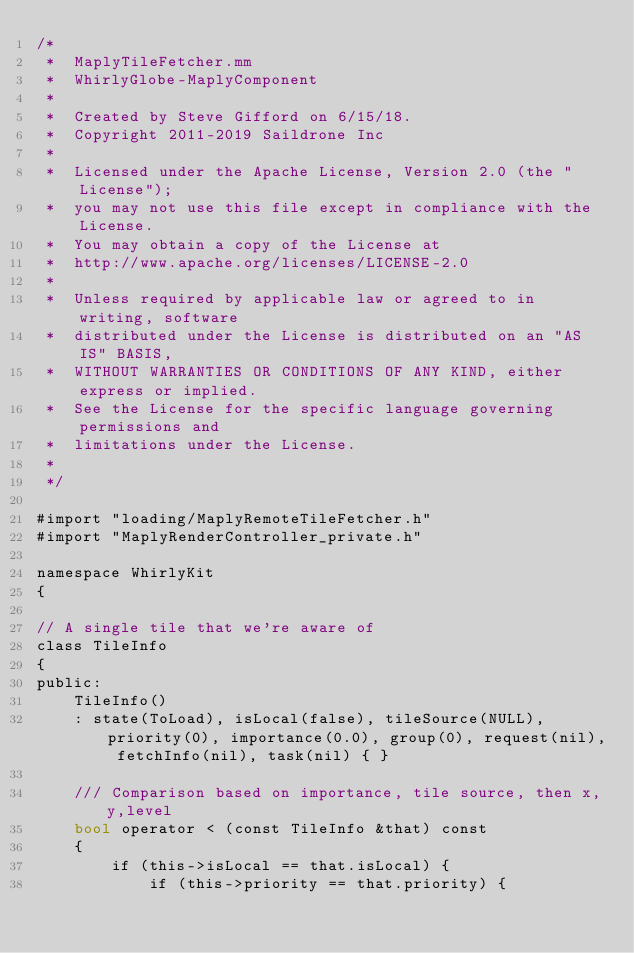<code> <loc_0><loc_0><loc_500><loc_500><_ObjectiveC_>/*
 *  MaplyTileFetcher.mm
 *  WhirlyGlobe-MaplyComponent
 *
 *  Created by Steve Gifford on 6/15/18.
 *  Copyright 2011-2019 Saildrone Inc
 *
 *  Licensed under the Apache License, Version 2.0 (the "License");
 *  you may not use this file except in compliance with the License.
 *  You may obtain a copy of the License at
 *  http://www.apache.org/licenses/LICENSE-2.0
 *
 *  Unless required by applicable law or agreed to in writing, software
 *  distributed under the License is distributed on an "AS IS" BASIS,
 *  WITHOUT WARRANTIES OR CONDITIONS OF ANY KIND, either express or implied.
 *  See the License for the specific language governing permissions and
 *  limitations under the License.
 *
 */

#import "loading/MaplyRemoteTileFetcher.h"
#import "MaplyRenderController_private.h"

namespace WhirlyKit
{

// A single tile that we're aware of
class TileInfo
{
public:
    TileInfo()
    : state(ToLoad), isLocal(false), tileSource(NULL), priority(0), importance(0.0), group(0), request(nil), fetchInfo(nil), task(nil) { }

    /// Comparison based on importance, tile source, then x,y,level
    bool operator < (const TileInfo &that) const
    {
        if (this->isLocal == that.isLocal) {
            if (this->priority == that.priority) {</code> 